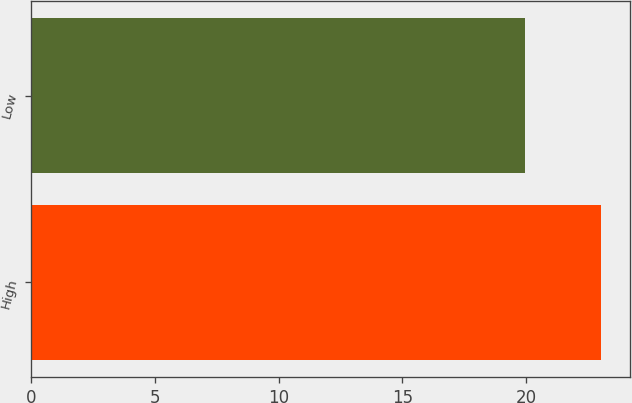Convert chart. <chart><loc_0><loc_0><loc_500><loc_500><bar_chart><fcel>High<fcel>Low<nl><fcel>23.04<fcel>19.97<nl></chart> 